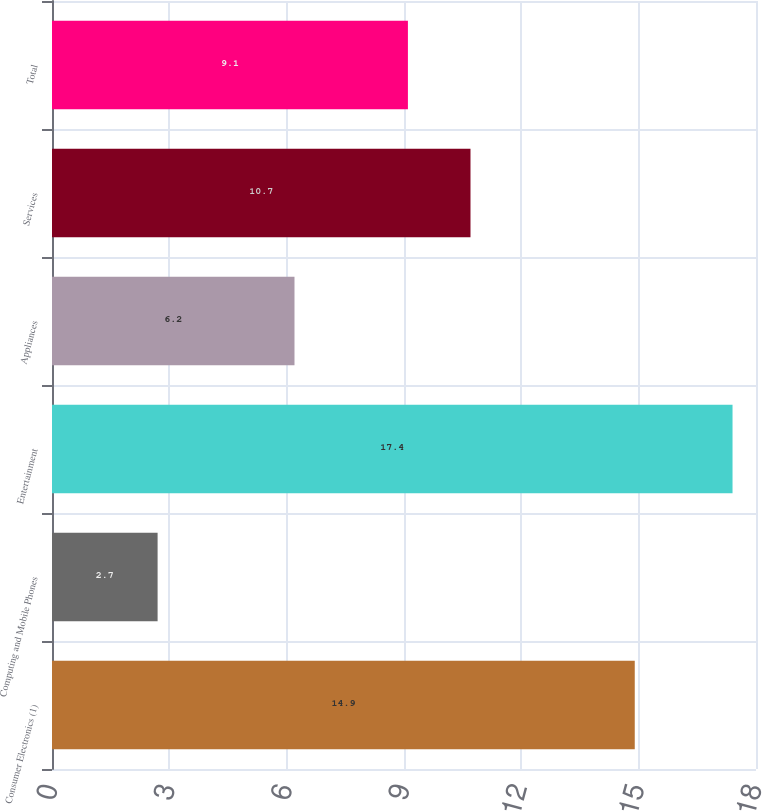<chart> <loc_0><loc_0><loc_500><loc_500><bar_chart><fcel>Consumer Electronics (1)<fcel>Computing and Mobile Phones<fcel>Entertainment<fcel>Appliances<fcel>Services<fcel>Total<nl><fcel>14.9<fcel>2.7<fcel>17.4<fcel>6.2<fcel>10.7<fcel>9.1<nl></chart> 